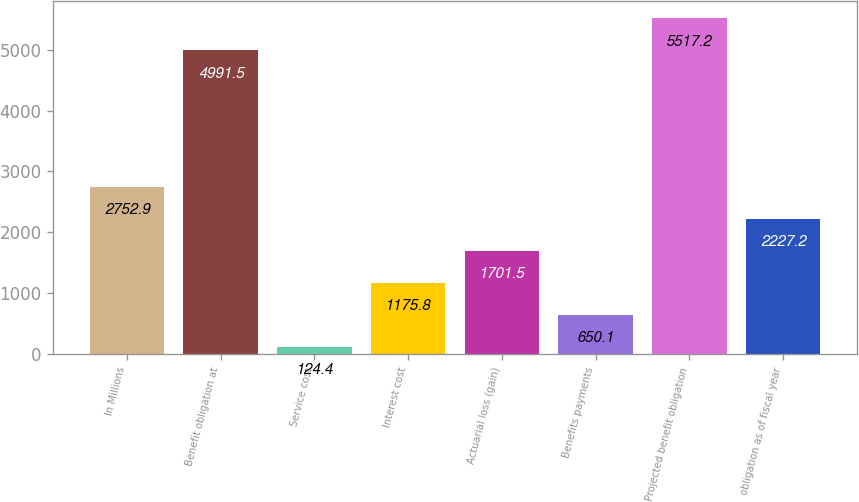Convert chart. <chart><loc_0><loc_0><loc_500><loc_500><bar_chart><fcel>In Millions<fcel>Benefit obligation at<fcel>Service cost<fcel>Interest cost<fcel>Actuarial loss (gain)<fcel>Benefits payments<fcel>Projected benefit obligation<fcel>obligation as of fiscal year<nl><fcel>2752.9<fcel>4991.5<fcel>124.4<fcel>1175.8<fcel>1701.5<fcel>650.1<fcel>5517.2<fcel>2227.2<nl></chart> 